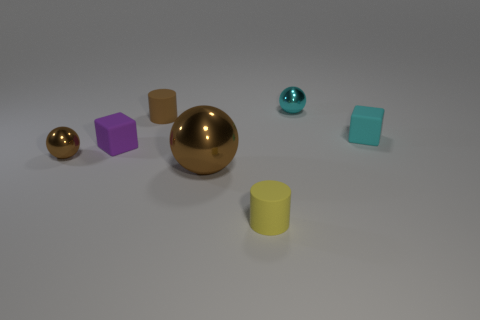Do the cyan rubber object and the yellow cylinder on the right side of the tiny brown matte object have the same size?
Offer a terse response. Yes. There is a tiny metallic sphere right of the tiny purple block; what color is it?
Provide a short and direct response. Cyan. What shape is the small matte object that is the same color as the big metallic ball?
Provide a short and direct response. Cylinder. The brown metallic object behind the big ball has what shape?
Provide a succinct answer. Sphere. What number of red objects are either metal things or tiny cylinders?
Keep it short and to the point. 0. Is the material of the big brown thing the same as the small yellow cylinder?
Your answer should be compact. No. What number of cyan shiny balls are in front of the large object?
Keep it short and to the point. 0. The thing that is both right of the brown rubber cylinder and behind the small cyan rubber thing is made of what material?
Offer a very short reply. Metal. What number of cylinders are either large brown metal things or red shiny objects?
Keep it short and to the point. 0. There is a small cyan thing that is the same shape as the large brown metallic object; what material is it?
Your response must be concise. Metal. 